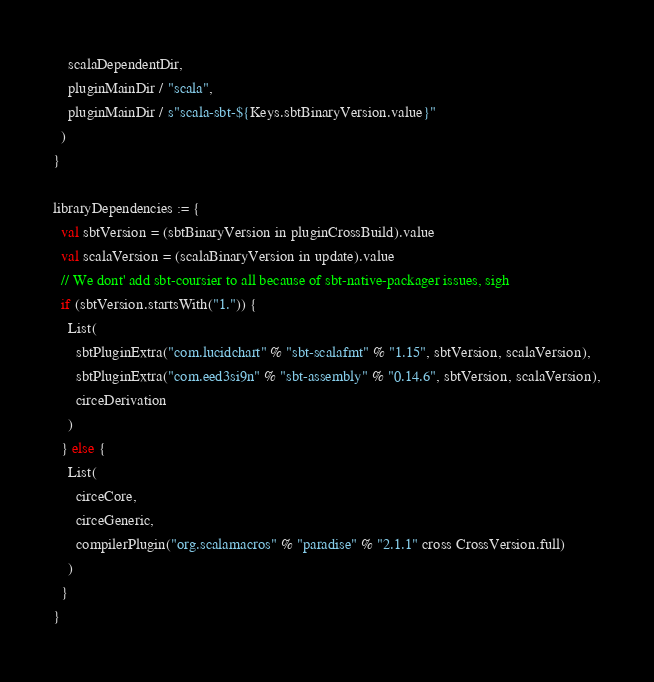<code> <loc_0><loc_0><loc_500><loc_500><_Scala_>    scalaDependentDir,
    pluginMainDir / "scala",
    pluginMainDir / s"scala-sbt-${Keys.sbtBinaryVersion.value}"
  )
}

libraryDependencies := {
  val sbtVersion = (sbtBinaryVersion in pluginCrossBuild).value
  val scalaVersion = (scalaBinaryVersion in update).value
  // We dont' add sbt-coursier to all because of sbt-native-packager issues, sigh
  if (sbtVersion.startsWith("1.")) {
    List(
      sbtPluginExtra("com.lucidchart" % "sbt-scalafmt" % "1.15", sbtVersion, scalaVersion),
      sbtPluginExtra("com.eed3si9n" % "sbt-assembly" % "0.14.6", sbtVersion, scalaVersion),
      circeDerivation
    )
  } else {
    List(
      circeCore,
      circeGeneric,
      compilerPlugin("org.scalamacros" % "paradise" % "2.1.1" cross CrossVersion.full)
    )
  }
}
</code> 